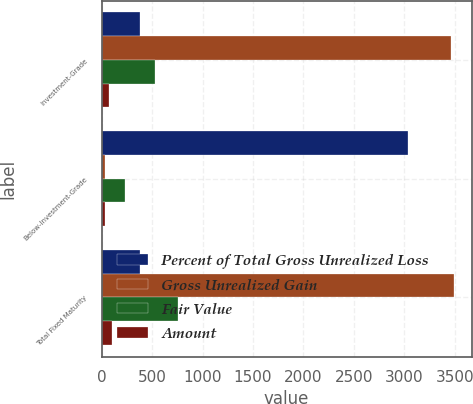Convert chart. <chart><loc_0><loc_0><loc_500><loc_500><stacked_bar_chart><ecel><fcel>Investment-Grade<fcel>Below-Investment-Grade<fcel>Total Fixed Maturity<nl><fcel>Percent of Total Gross Unrealized Loss<fcel>378.2<fcel>3038.6<fcel>378.2<nl><fcel>Gross Unrealized Gain<fcel>3464.2<fcel>28.7<fcel>3492.9<nl><fcel>Fair Value<fcel>529.5<fcel>226.9<fcel>756.4<nl><fcel>Amount<fcel>70<fcel>30<fcel>100<nl></chart> 